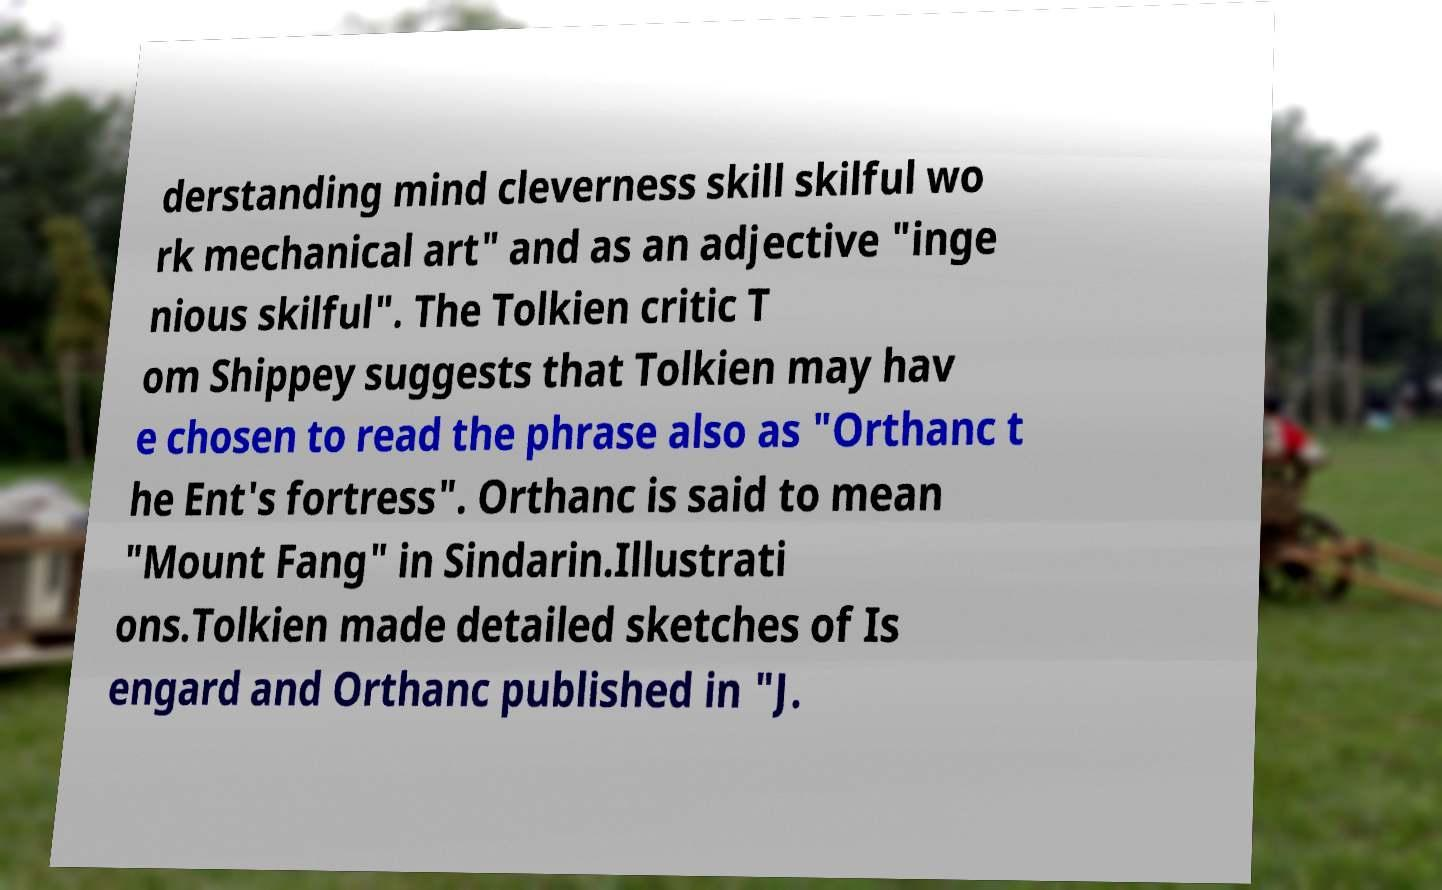Please identify and transcribe the text found in this image. derstanding mind cleverness skill skilful wo rk mechanical art" and as an adjective "inge nious skilful". The Tolkien critic T om Shippey suggests that Tolkien may hav e chosen to read the phrase also as "Orthanc t he Ent's fortress". Orthanc is said to mean "Mount Fang" in Sindarin.Illustrati ons.Tolkien made detailed sketches of Is engard and Orthanc published in "J. 